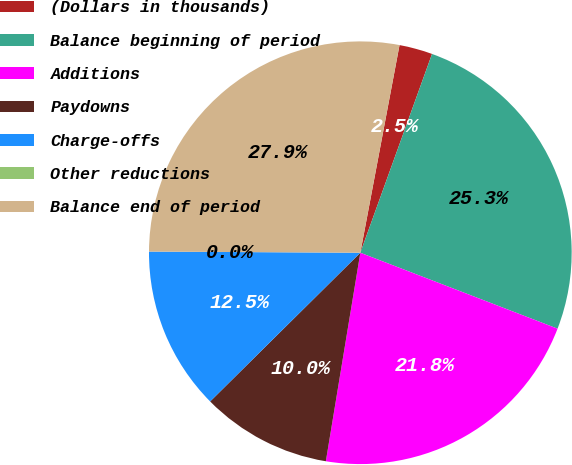Convert chart. <chart><loc_0><loc_0><loc_500><loc_500><pie_chart><fcel>(Dollars in thousands)<fcel>Balance beginning of period<fcel>Additions<fcel>Paydowns<fcel>Charge-offs<fcel>Other reductions<fcel>Balance end of period<nl><fcel>2.54%<fcel>25.34%<fcel>21.76%<fcel>9.97%<fcel>12.51%<fcel>0.0%<fcel>27.88%<nl></chart> 